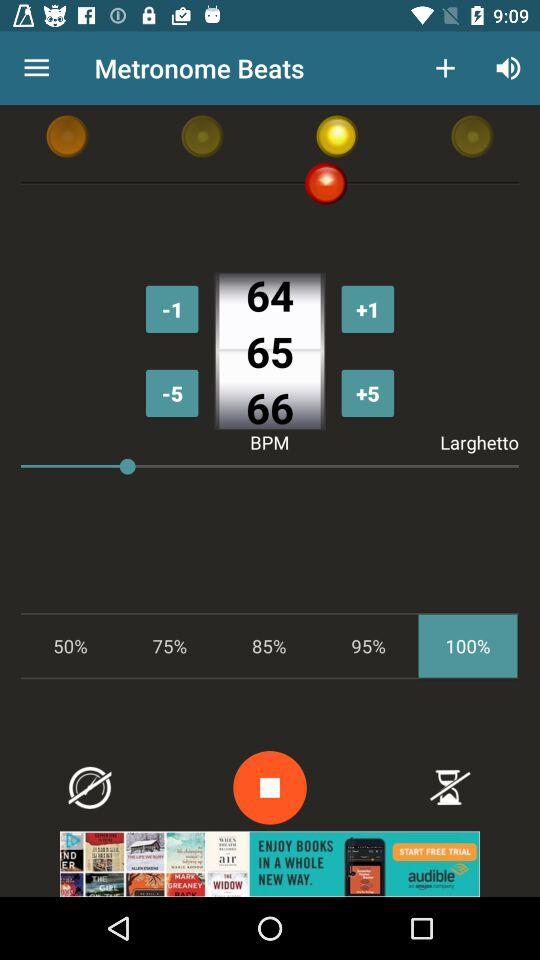How many more yellow circles are there than red circles?
Answer the question using a single word or phrase. 3 